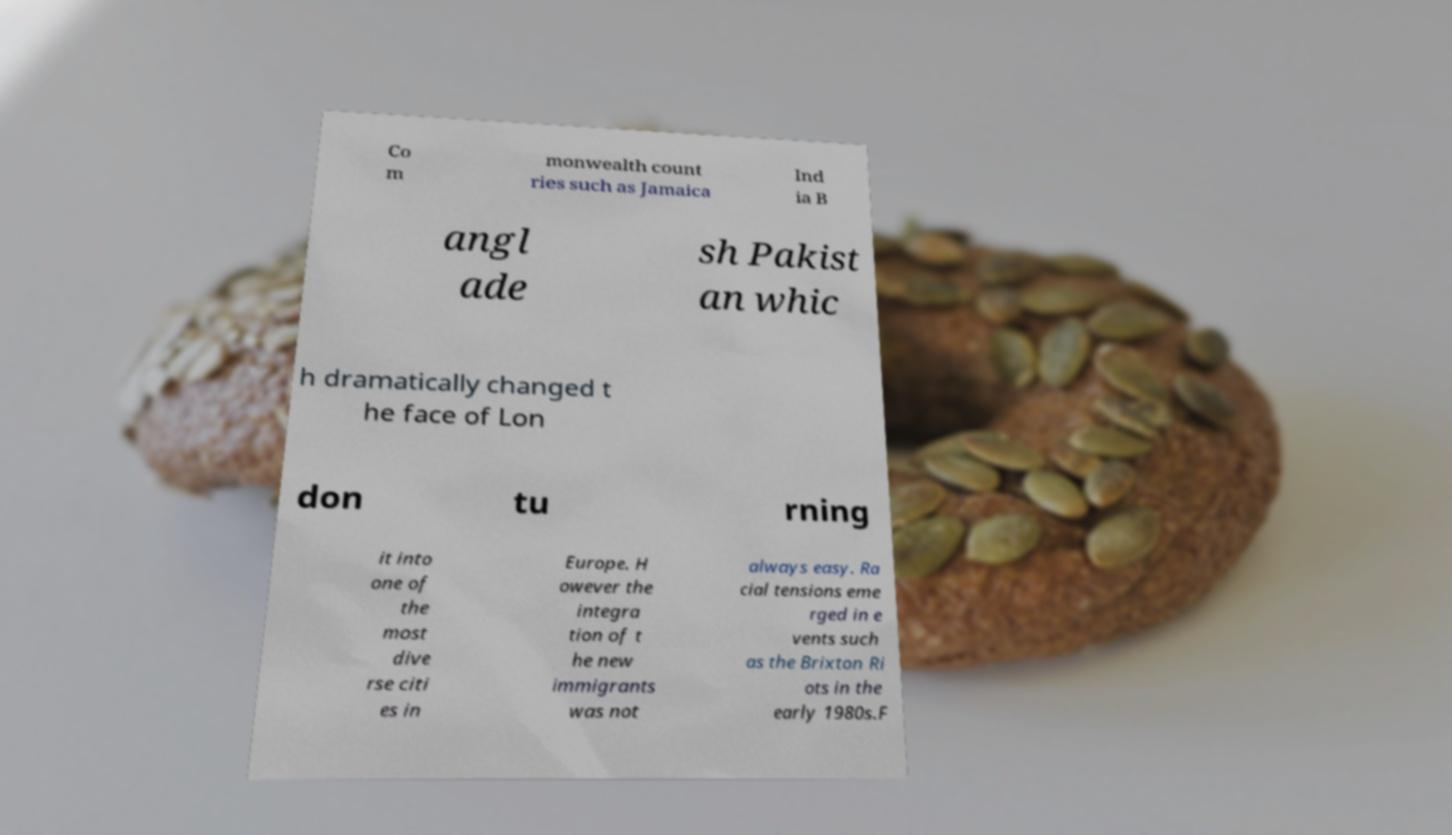Can you read and provide the text displayed in the image?This photo seems to have some interesting text. Can you extract and type it out for me? Co m monwealth count ries such as Jamaica Ind ia B angl ade sh Pakist an whic h dramatically changed t he face of Lon don tu rning it into one of the most dive rse citi es in Europe. H owever the integra tion of t he new immigrants was not always easy. Ra cial tensions eme rged in e vents such as the Brixton Ri ots in the early 1980s.F 